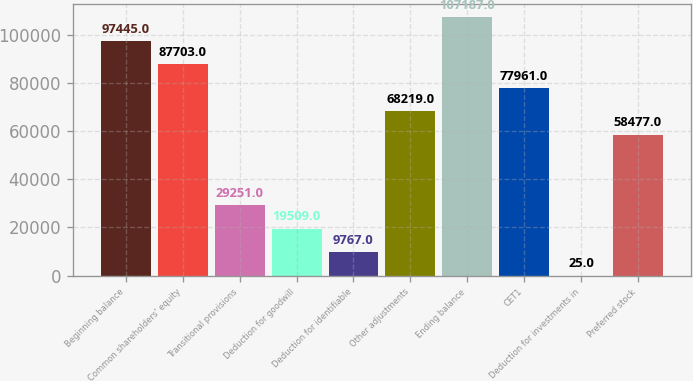<chart> <loc_0><loc_0><loc_500><loc_500><bar_chart><fcel>Beginning balance<fcel>Common shareholders' equity<fcel>Transitional provisions<fcel>Deduction for goodwill<fcel>Deduction for identifiable<fcel>Other adjustments<fcel>Ending balance<fcel>CET1<fcel>Deduction for investments in<fcel>Preferred stock<nl><fcel>97445<fcel>87703<fcel>29251<fcel>19509<fcel>9767<fcel>68219<fcel>107187<fcel>77961<fcel>25<fcel>58477<nl></chart> 